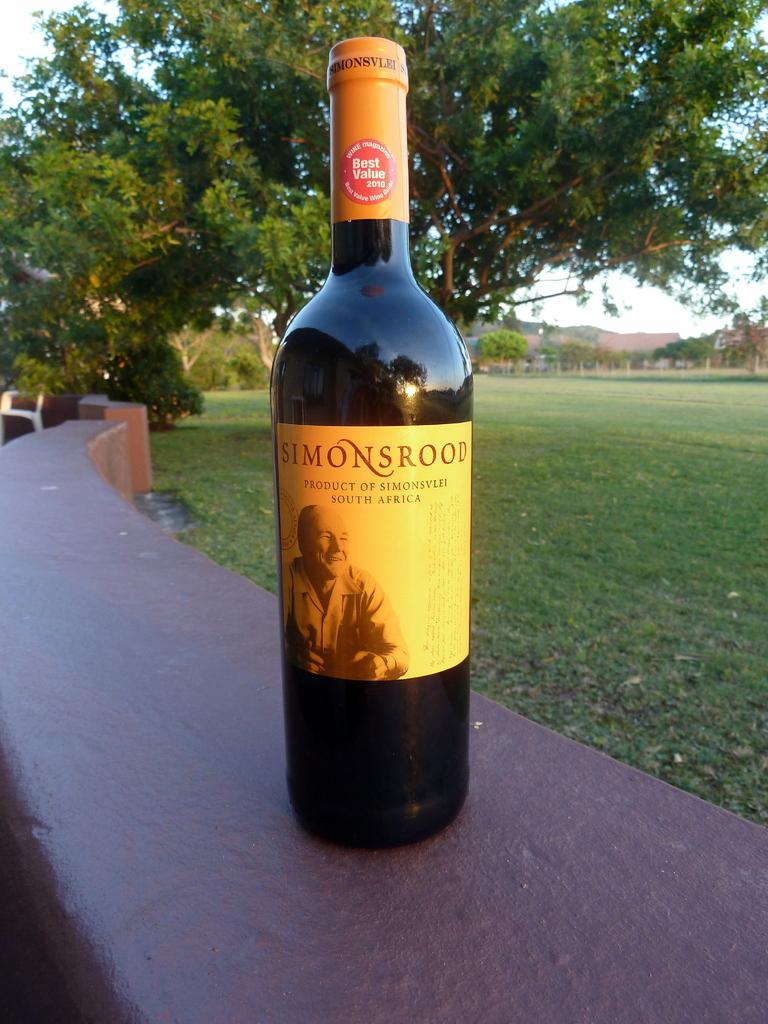Provide a one-sentence caption for the provided image. Bottle of alcohol named Simonsrood outdoors on a table. 